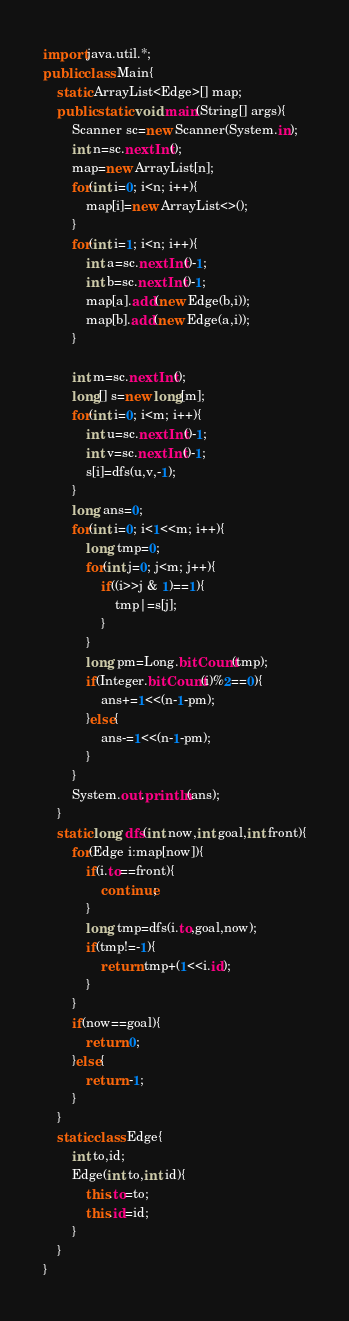<code> <loc_0><loc_0><loc_500><loc_500><_Java_>import java.util.*;
public class Main{
	static ArrayList<Edge>[] map;
	public static void main(String[] args){
		Scanner sc=new Scanner(System.in);
		int n=sc.nextInt();
		map=new ArrayList[n];
		for(int i=0; i<n; i++){
			map[i]=new ArrayList<>();
		}
		for(int i=1; i<n; i++){
			int a=sc.nextInt()-1;
			int b=sc.nextInt()-1;
			map[a].add(new Edge(b,i));
			map[b].add(new Edge(a,i));
		}
		
		int m=sc.nextInt();
		long[] s=new long[m];
		for(int i=0; i<m; i++){
			int u=sc.nextInt()-1;
			int v=sc.nextInt()-1;
			s[i]=dfs(u,v,-1);
		}
		long ans=0;
		for(int i=0; i<1<<m; i++){
			long tmp=0;
			for(int j=0; j<m; j++){
				if((i>>j & 1)==1){
					tmp|=s[j];
				}
			}
			long pm=Long.bitCount(tmp);
			if(Integer.bitCount(i)%2==0){
				ans+=1<<(n-1-pm);
			}else{
				ans-=1<<(n-1-pm);
			}
		}
		System.out.println(ans);
	}
	static long dfs(int now,int goal,int front){
		for(Edge i:map[now]){
			if(i.to==front){
				continue;
			}
			long tmp=dfs(i.to,goal,now);
			if(tmp!=-1){
				return tmp+(1<<i.id);
			}
		}
		if(now==goal){
			return 0;
		}else{
			return -1;
		}
	}
	static class Edge{
		int to,id;
		Edge(int to,int id){
			this.to=to;
			this.id=id;
		}
	}
}
</code> 